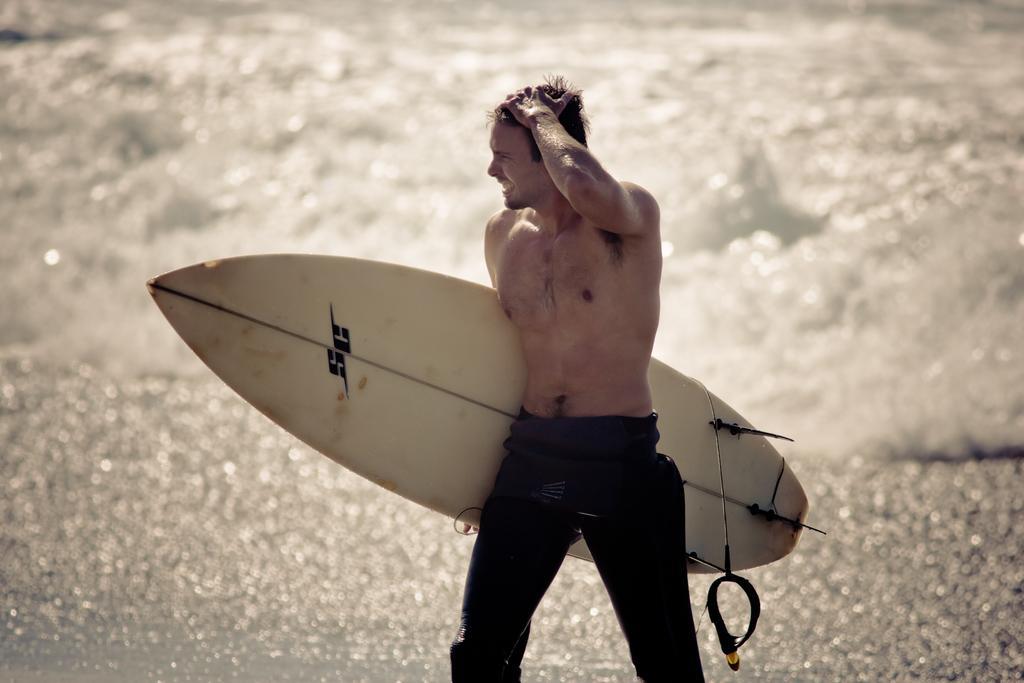How would you summarize this image in a sentence or two? out side of the road person he is walking on the road and he is holding the surfboard. 